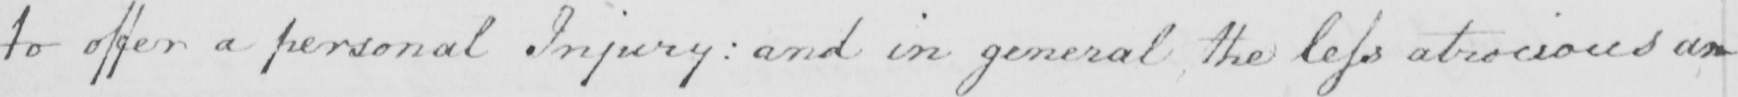What does this handwritten line say? to offer a personal Injury :  and in general the less atrocious an 